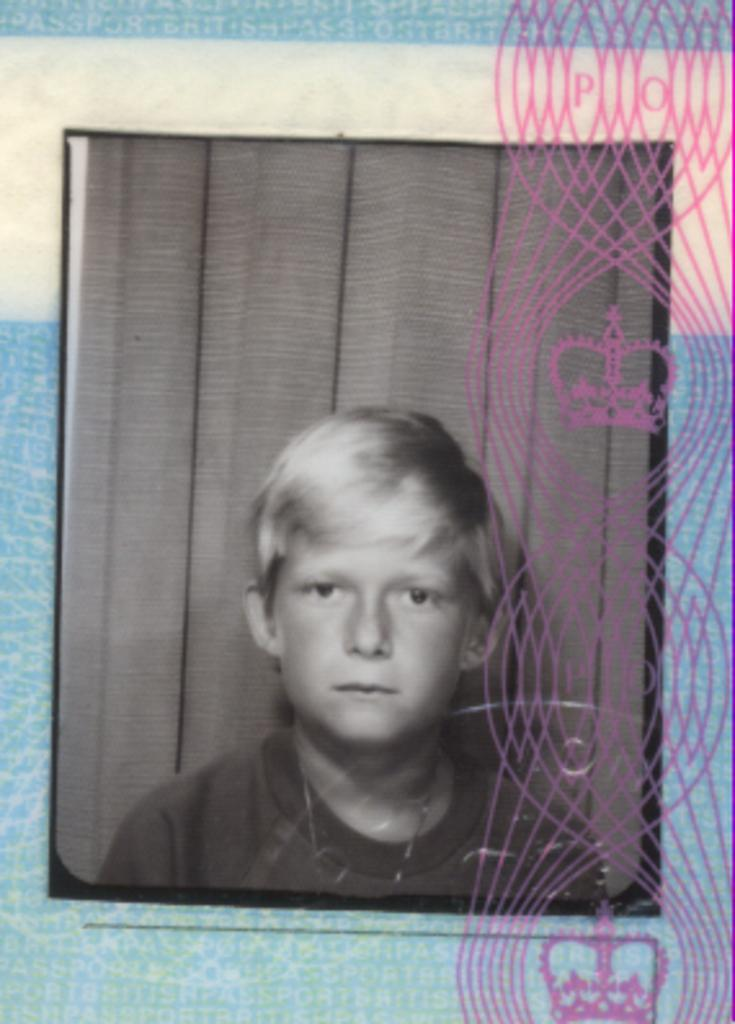What is the main subject of the image? There is a photo of a boy in the image. What is the photo placed on? The photo is on a cloth. What can be seen on the right side of the image? There are logos and designs on the right side of the image. How many drops of water can be seen on the photo of the boy? There are no drops of water visible on the photo of the boy in the image. What type of furniture is present in the image? There is no furniture present in the image; it only features a photo of a boy on a cloth with logos and designs on the right side. 